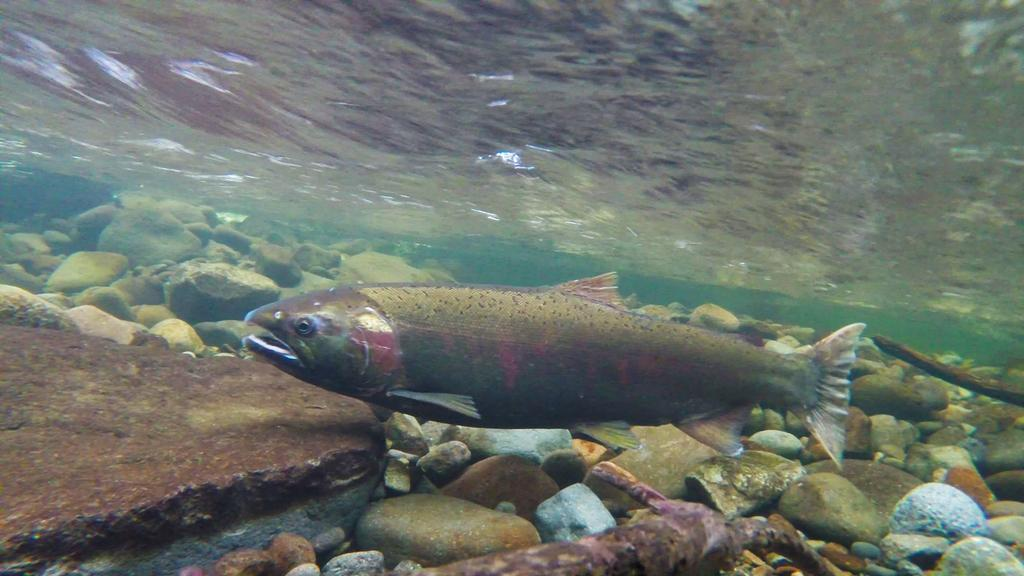Where was the image taken? The image was taken underwater. What can be seen in the image besides the underwater environment? There is a fish in the image. In which direction is the fish facing? The fish is facing towards the left side. What is visible at the bottom of the image? There are many stones at the bottom of the image. What type of mist can be seen in the image? There is no mist present in the image, as it was taken underwater. 